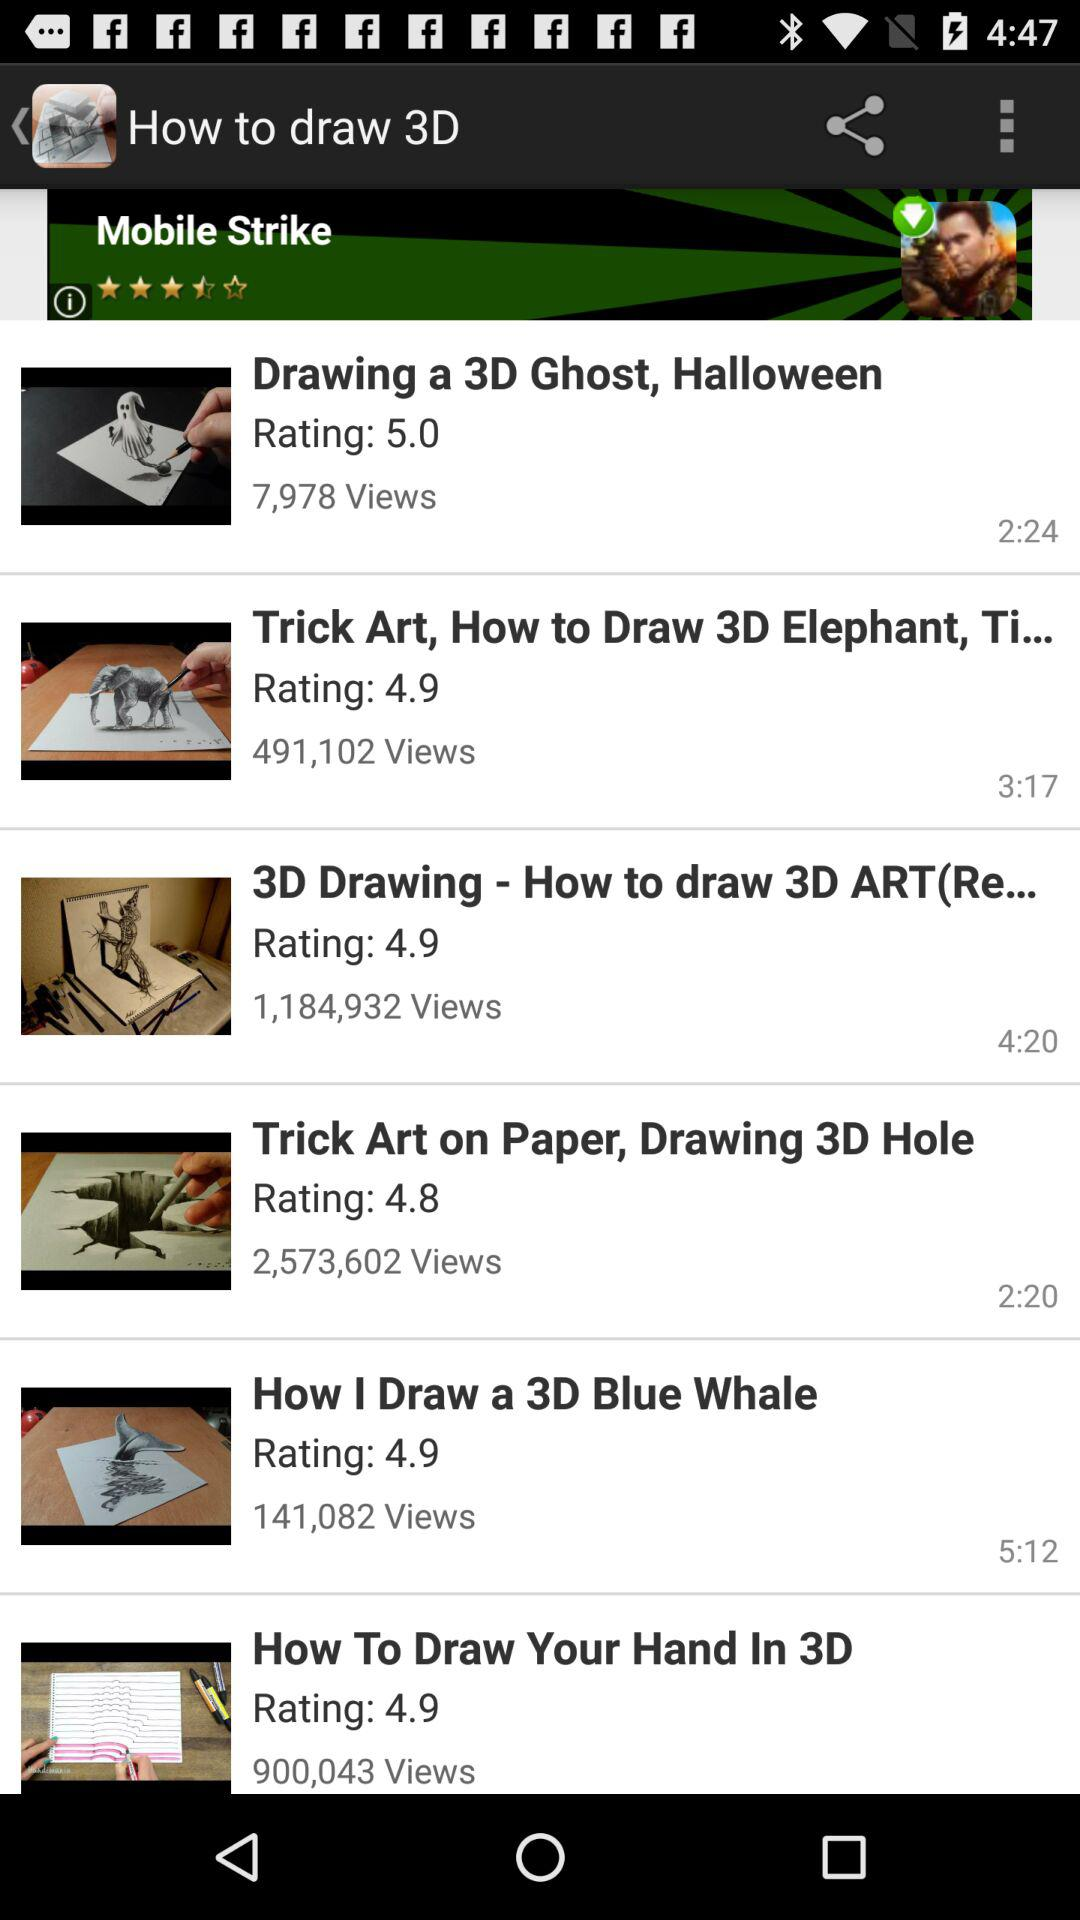How many 3D drawings have 4.9 ratings?
When the provided information is insufficient, respond with <no answer>. <no answer> 